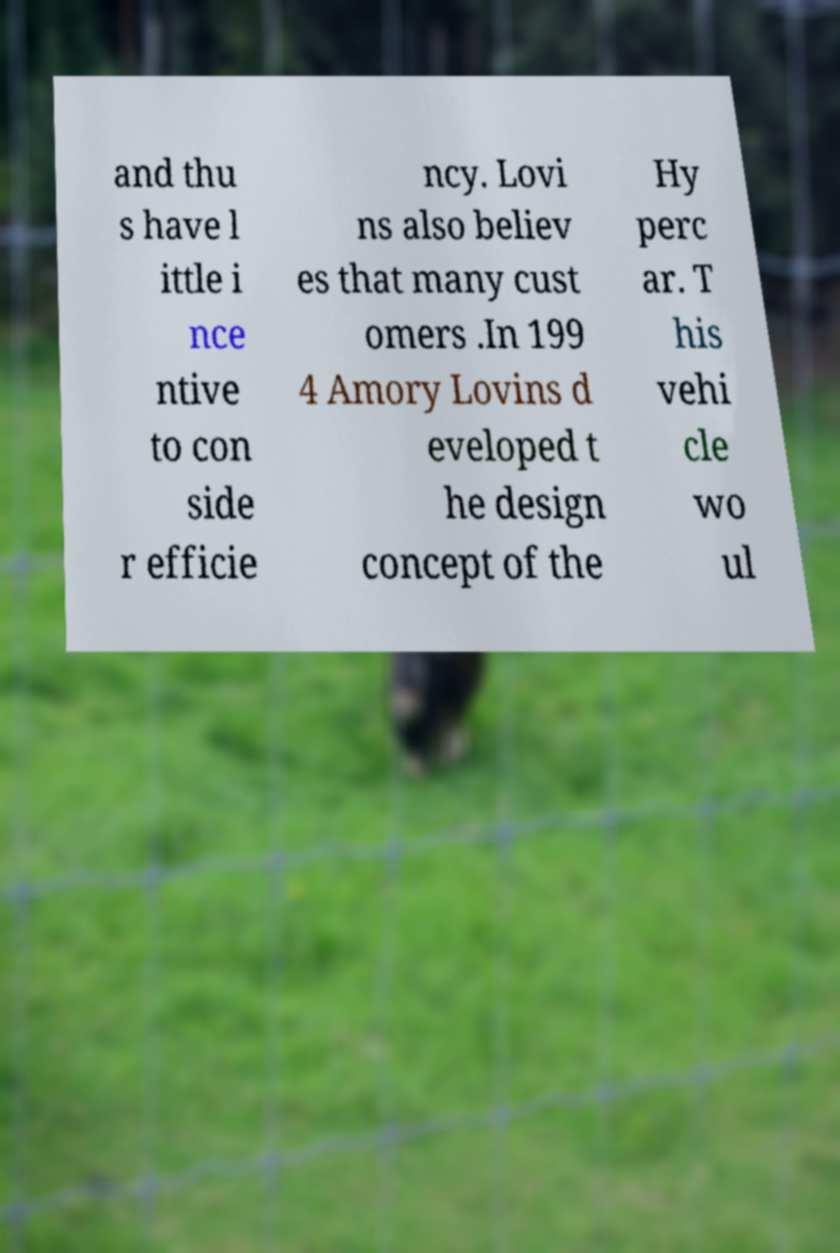Could you extract and type out the text from this image? and thu s have l ittle i nce ntive to con side r efficie ncy. Lovi ns also believ es that many cust omers .In 199 4 Amory Lovins d eveloped t he design concept of the Hy perc ar. T his vehi cle wo ul 